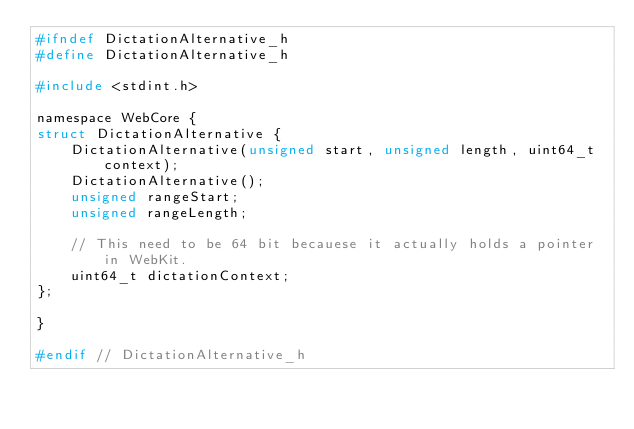<code> <loc_0><loc_0><loc_500><loc_500><_C_>#ifndef DictationAlternative_h
#define DictationAlternative_h

#include <stdint.h>

namespace WebCore {
struct DictationAlternative {
    DictationAlternative(unsigned start, unsigned length, uint64_t context);
    DictationAlternative();
    unsigned rangeStart;
    unsigned rangeLength;

    // This need to be 64 bit becauese it actually holds a pointer in WebKit.
    uint64_t dictationContext;
};

}

#endif // DictationAlternative_h
</code> 